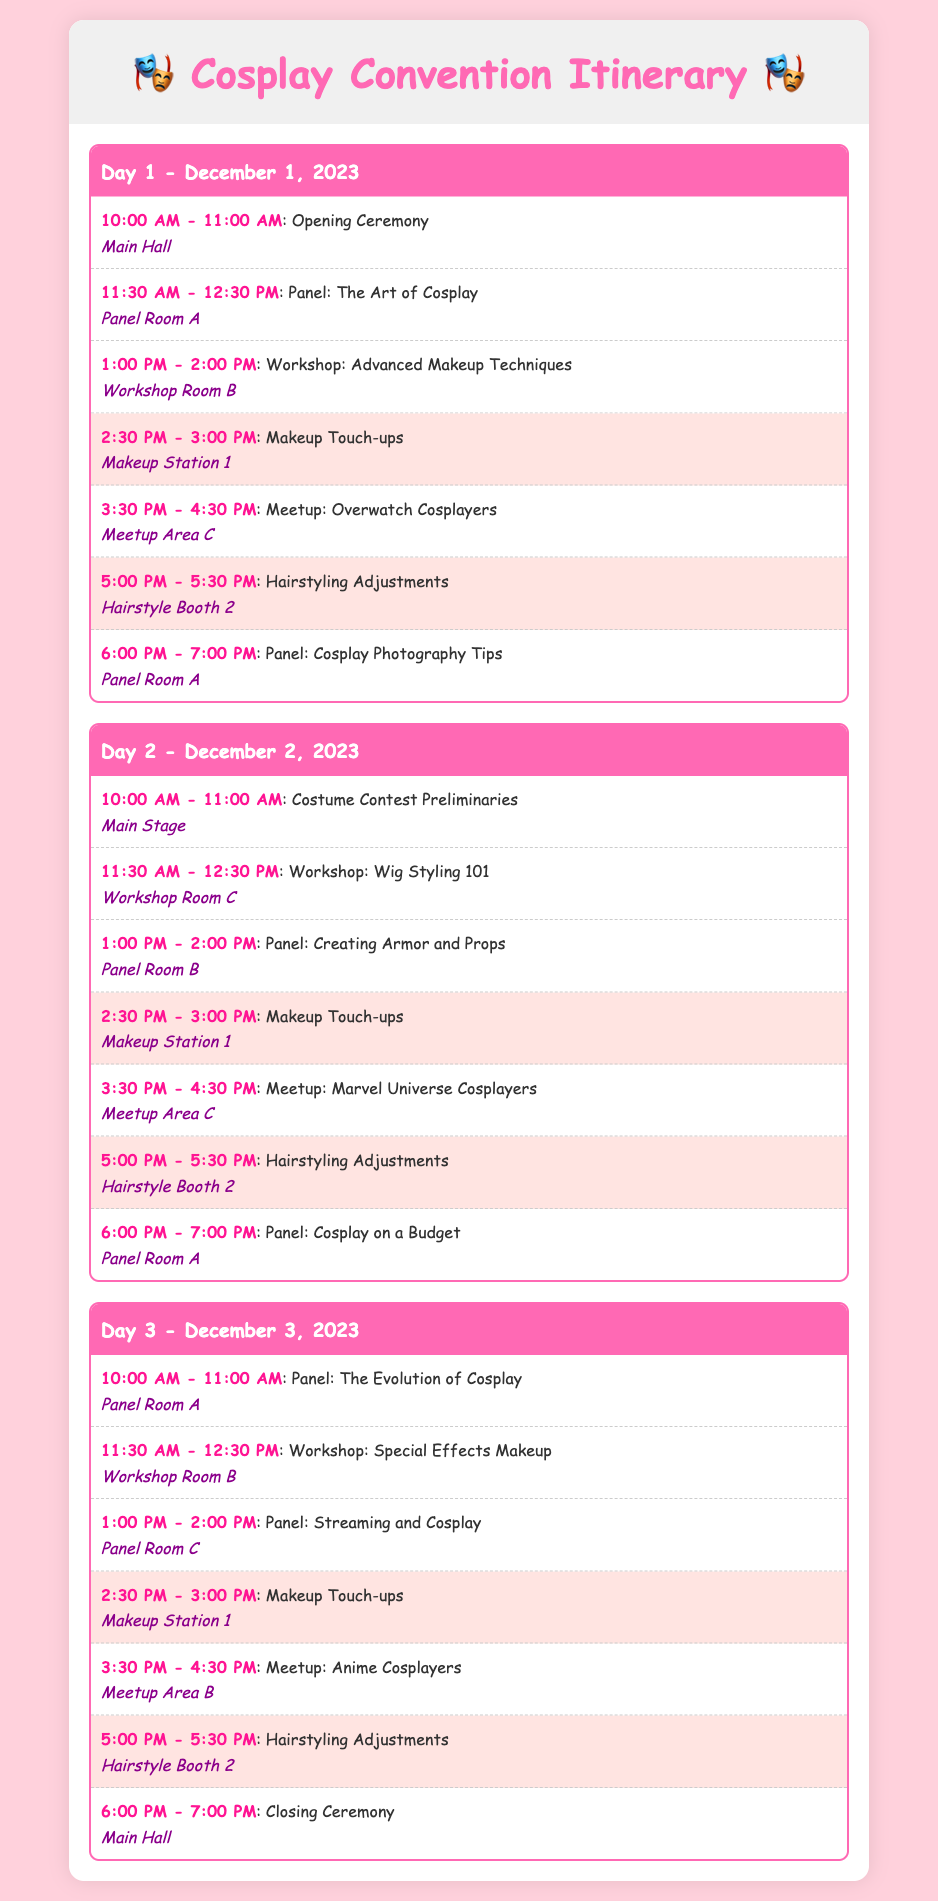What time does the Opening Ceremony start? The Opening Ceremony starts at 10:00 AM on Day 1, as detailed in the itinerary.
Answer: 10:00 AM Where is the Advanced Makeup Techniques workshop located? The Advanced Makeup Techniques workshop takes place in Workshop Room B on Day 1.
Answer: Workshop Room B On which day is the Panel: Cosplay on a Budget scheduled? The Panel: Cosplay on a Budget is scheduled for Day 2.
Answer: Day 2 How long are the Makeup Touch-ups sessions? Each Makeup Touch-ups session lasts 30 minutes, as indicated in the schedule.
Answer: 30 minutes What is the last event on Day 3? The last event on Day 3 is the Closing Ceremony, which is scheduled for 6:00 PM.
Answer: Closing Ceremony What are the locations for Hairstyling Adjustments? Hairstyling Adjustments occur at Hairstyle Booth 2 on both Day 1 and Day 2.
Answer: Hairstyle Booth 2 What type of event is scheduled at 3:30 PM on Day 2? At 3:30 PM on Day 2, there is a Meetup for Marvel Universe Cosplayers listed in the itinerary.
Answer: Meetup: Marvel Universe Cosplayers What is the theme of the meetup at 3:30 PM on Day 1? The theme of the meetup at 3:30 PM on Day 1 is Overwatch Cosplayers.
Answer: Overwatch Cosplayers How many workshops are mentioned in the itinerary? There are three workshops listed in the itinerary across the three days.
Answer: Three workshops 